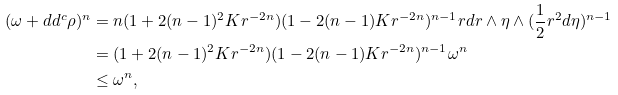<formula> <loc_0><loc_0><loc_500><loc_500>( \omega + d d ^ { c } \rho ) ^ { n } & = n ( 1 + 2 ( n - 1 ) ^ { 2 } K r ^ { - 2 n } ) ( 1 - 2 ( n - 1 ) K r ^ { - 2 n } ) ^ { n - 1 } r d r \wedge \eta \wedge ( \frac { 1 } { 2 } r ^ { 2 } d \eta ) ^ { n - 1 } \\ & = ( 1 + 2 ( n - 1 ) ^ { 2 } K r ^ { - 2 n } ) ( 1 - 2 ( n - 1 ) K r ^ { - 2 n } ) ^ { n - 1 } \omega ^ { n } \\ & \leq \omega ^ { n } ,</formula> 